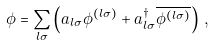<formula> <loc_0><loc_0><loc_500><loc_500>\phi = \sum _ { l \sigma } \left ( a _ { l \sigma } \phi ^ { ( l \sigma ) } + a _ { l \sigma } ^ { \dagger } \overline { \phi ^ { ( l \sigma ) } } \right ) \, ,</formula> 